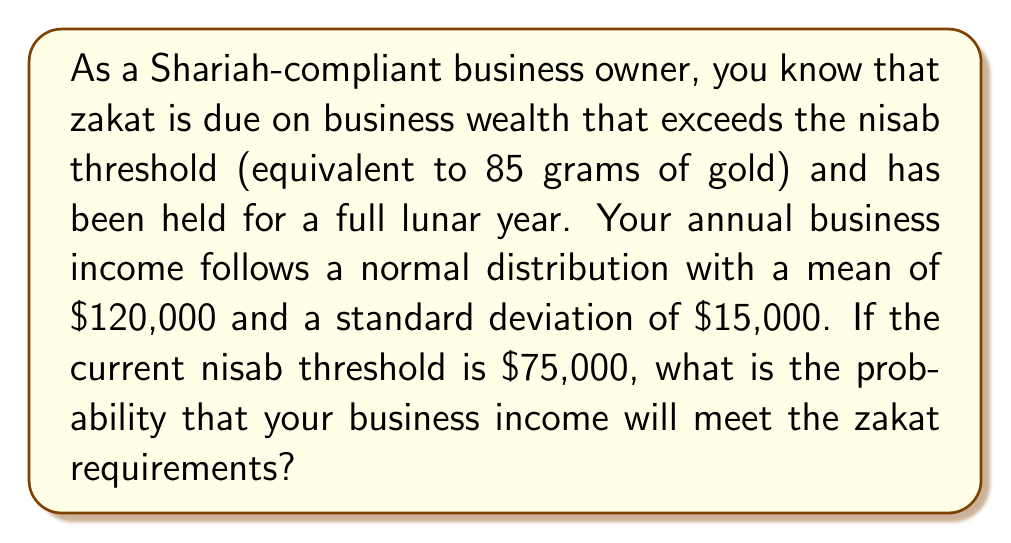Can you answer this question? To solve this problem, we need to follow these steps:

1. Identify the relevant information:
   - Business income follows a normal distribution
   - Mean (μ) = $120,000
   - Standard deviation (σ) = $15,000
   - Nisab threshold = $75,000

2. We need to find the probability that the business income is greater than $75,000.

3. Standardize the nisab threshold to calculate the z-score:
   $$ z = \frac{x - \mu}{\sigma} = \frac{75,000 - 120,000}{15,000} = -3 $$

4. The probability we're looking for is the area to the right of z = -3 on the standard normal distribution.

5. Using a standard normal distribution table or calculator, we find:
   $$ P(Z > -3) = 1 - P(Z < -3) = 1 - 0.00135 = 0.99865 $$

6. Convert the probability to a percentage:
   0.99865 × 100% = 99.865%

Therefore, the probability that your business income will meet the zakat requirements is approximately 99.865%.
Answer: 99.865% 